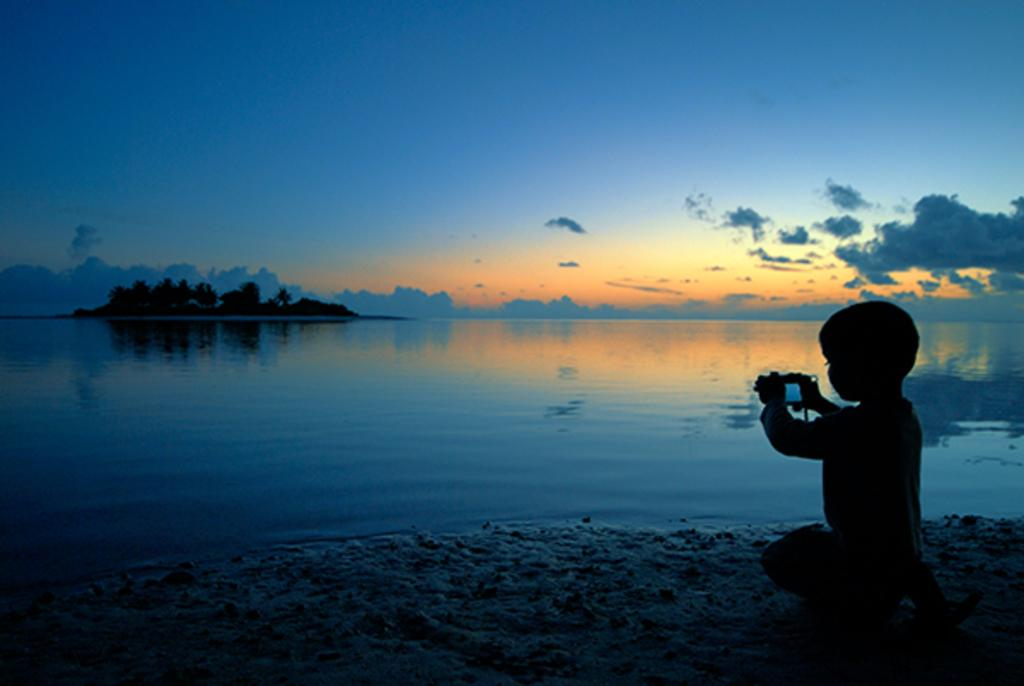What is the main subject of the image? The main subject of the image is a kid. What is the kid doing in the image? The kid is using a cell phone and taking a picture. What can be seen in the background of the image? There are trees, a river, and the sky visible in the image. What type of wrench is the kid using to take a picture in the image? There is no wrench present in the image; the kid is using a cell phone to take a picture. How many cakes can be seen in the image? There are no cakes present in the image. 